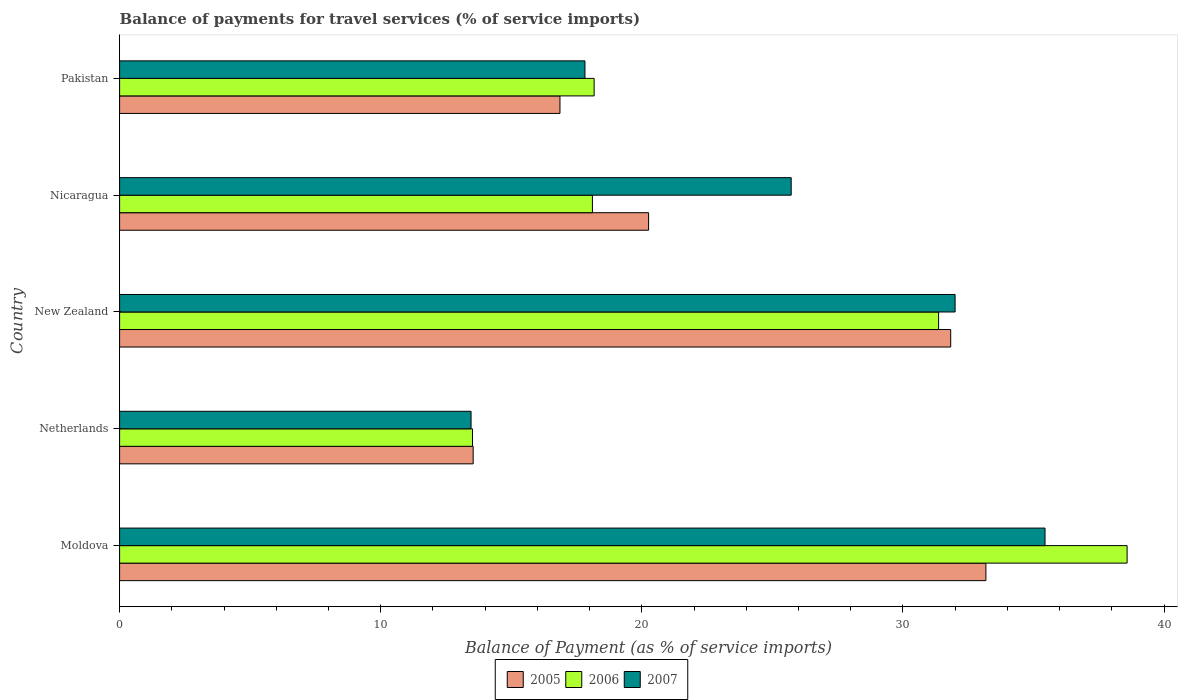How many groups of bars are there?
Provide a succinct answer. 5. Are the number of bars per tick equal to the number of legend labels?
Make the answer very short. Yes. How many bars are there on the 5th tick from the bottom?
Your answer should be very brief. 3. What is the label of the 2nd group of bars from the top?
Your response must be concise. Nicaragua. What is the balance of payments for travel services in 2006 in Nicaragua?
Keep it short and to the point. 18.11. Across all countries, what is the maximum balance of payments for travel services in 2005?
Give a very brief answer. 33.18. Across all countries, what is the minimum balance of payments for travel services in 2006?
Your answer should be very brief. 13.51. In which country was the balance of payments for travel services in 2005 maximum?
Provide a short and direct response. Moldova. In which country was the balance of payments for travel services in 2007 minimum?
Make the answer very short. Netherlands. What is the total balance of payments for travel services in 2007 in the graph?
Provide a succinct answer. 124.44. What is the difference between the balance of payments for travel services in 2006 in Nicaragua and that in Pakistan?
Offer a terse response. -0.07. What is the difference between the balance of payments for travel services in 2006 in New Zealand and the balance of payments for travel services in 2007 in Netherlands?
Your answer should be very brief. 17.91. What is the average balance of payments for travel services in 2007 per country?
Offer a very short reply. 24.89. What is the difference between the balance of payments for travel services in 2007 and balance of payments for travel services in 2005 in New Zealand?
Your response must be concise. 0.17. In how many countries, is the balance of payments for travel services in 2007 greater than 26 %?
Your answer should be very brief. 2. What is the ratio of the balance of payments for travel services in 2005 in New Zealand to that in Pakistan?
Provide a short and direct response. 1.89. Is the balance of payments for travel services in 2006 in Nicaragua less than that in Pakistan?
Keep it short and to the point. Yes. What is the difference between the highest and the second highest balance of payments for travel services in 2005?
Provide a succinct answer. 1.35. What is the difference between the highest and the lowest balance of payments for travel services in 2007?
Give a very brief answer. 21.98. Is the sum of the balance of payments for travel services in 2005 in Netherlands and Nicaragua greater than the maximum balance of payments for travel services in 2007 across all countries?
Your response must be concise. No. What does the 2nd bar from the top in Pakistan represents?
Provide a succinct answer. 2006. Is it the case that in every country, the sum of the balance of payments for travel services in 2006 and balance of payments for travel services in 2007 is greater than the balance of payments for travel services in 2005?
Make the answer very short. Yes. Are all the bars in the graph horizontal?
Provide a succinct answer. Yes. How many countries are there in the graph?
Make the answer very short. 5. Does the graph contain any zero values?
Your answer should be compact. No. Does the graph contain grids?
Your answer should be compact. No. How many legend labels are there?
Make the answer very short. 3. How are the legend labels stacked?
Provide a succinct answer. Horizontal. What is the title of the graph?
Provide a succinct answer. Balance of payments for travel services (% of service imports). Does "1986" appear as one of the legend labels in the graph?
Your answer should be very brief. No. What is the label or title of the X-axis?
Ensure brevity in your answer.  Balance of Payment (as % of service imports). What is the Balance of Payment (as % of service imports) in 2005 in Moldova?
Your answer should be very brief. 33.18. What is the Balance of Payment (as % of service imports) in 2006 in Moldova?
Give a very brief answer. 38.58. What is the Balance of Payment (as % of service imports) of 2007 in Moldova?
Offer a terse response. 35.44. What is the Balance of Payment (as % of service imports) in 2005 in Netherlands?
Provide a succinct answer. 13.54. What is the Balance of Payment (as % of service imports) in 2006 in Netherlands?
Your answer should be compact. 13.51. What is the Balance of Payment (as % of service imports) in 2007 in Netherlands?
Your response must be concise. 13.46. What is the Balance of Payment (as % of service imports) in 2005 in New Zealand?
Keep it short and to the point. 31.83. What is the Balance of Payment (as % of service imports) in 2006 in New Zealand?
Ensure brevity in your answer.  31.36. What is the Balance of Payment (as % of service imports) of 2007 in New Zealand?
Your answer should be very brief. 32. What is the Balance of Payment (as % of service imports) in 2005 in Nicaragua?
Make the answer very short. 20.26. What is the Balance of Payment (as % of service imports) in 2006 in Nicaragua?
Provide a succinct answer. 18.11. What is the Balance of Payment (as % of service imports) in 2007 in Nicaragua?
Your answer should be very brief. 25.72. What is the Balance of Payment (as % of service imports) of 2005 in Pakistan?
Keep it short and to the point. 16.86. What is the Balance of Payment (as % of service imports) in 2006 in Pakistan?
Keep it short and to the point. 18.17. What is the Balance of Payment (as % of service imports) of 2007 in Pakistan?
Your response must be concise. 17.82. Across all countries, what is the maximum Balance of Payment (as % of service imports) of 2005?
Give a very brief answer. 33.18. Across all countries, what is the maximum Balance of Payment (as % of service imports) in 2006?
Give a very brief answer. 38.58. Across all countries, what is the maximum Balance of Payment (as % of service imports) in 2007?
Offer a terse response. 35.44. Across all countries, what is the minimum Balance of Payment (as % of service imports) of 2005?
Provide a short and direct response. 13.54. Across all countries, what is the minimum Balance of Payment (as % of service imports) in 2006?
Provide a succinct answer. 13.51. Across all countries, what is the minimum Balance of Payment (as % of service imports) in 2007?
Make the answer very short. 13.46. What is the total Balance of Payment (as % of service imports) in 2005 in the graph?
Provide a succinct answer. 115.67. What is the total Balance of Payment (as % of service imports) of 2006 in the graph?
Provide a short and direct response. 119.74. What is the total Balance of Payment (as % of service imports) of 2007 in the graph?
Keep it short and to the point. 124.44. What is the difference between the Balance of Payment (as % of service imports) of 2005 in Moldova and that in Netherlands?
Your response must be concise. 19.64. What is the difference between the Balance of Payment (as % of service imports) in 2006 in Moldova and that in Netherlands?
Keep it short and to the point. 25.07. What is the difference between the Balance of Payment (as % of service imports) in 2007 in Moldova and that in Netherlands?
Make the answer very short. 21.98. What is the difference between the Balance of Payment (as % of service imports) in 2005 in Moldova and that in New Zealand?
Provide a succinct answer. 1.35. What is the difference between the Balance of Payment (as % of service imports) in 2006 in Moldova and that in New Zealand?
Make the answer very short. 7.22. What is the difference between the Balance of Payment (as % of service imports) in 2007 in Moldova and that in New Zealand?
Make the answer very short. 3.44. What is the difference between the Balance of Payment (as % of service imports) in 2005 in Moldova and that in Nicaragua?
Provide a short and direct response. 12.92. What is the difference between the Balance of Payment (as % of service imports) of 2006 in Moldova and that in Nicaragua?
Keep it short and to the point. 20.48. What is the difference between the Balance of Payment (as % of service imports) in 2007 in Moldova and that in Nicaragua?
Your answer should be very brief. 9.72. What is the difference between the Balance of Payment (as % of service imports) of 2005 in Moldova and that in Pakistan?
Ensure brevity in your answer.  16.31. What is the difference between the Balance of Payment (as % of service imports) in 2006 in Moldova and that in Pakistan?
Your answer should be compact. 20.41. What is the difference between the Balance of Payment (as % of service imports) of 2007 in Moldova and that in Pakistan?
Provide a succinct answer. 17.62. What is the difference between the Balance of Payment (as % of service imports) of 2005 in Netherlands and that in New Zealand?
Offer a very short reply. -18.29. What is the difference between the Balance of Payment (as % of service imports) in 2006 in Netherlands and that in New Zealand?
Offer a terse response. -17.85. What is the difference between the Balance of Payment (as % of service imports) of 2007 in Netherlands and that in New Zealand?
Keep it short and to the point. -18.54. What is the difference between the Balance of Payment (as % of service imports) of 2005 in Netherlands and that in Nicaragua?
Provide a succinct answer. -6.72. What is the difference between the Balance of Payment (as % of service imports) of 2006 in Netherlands and that in Nicaragua?
Ensure brevity in your answer.  -4.59. What is the difference between the Balance of Payment (as % of service imports) in 2007 in Netherlands and that in Nicaragua?
Your answer should be very brief. -12.26. What is the difference between the Balance of Payment (as % of service imports) in 2005 in Netherlands and that in Pakistan?
Provide a short and direct response. -3.32. What is the difference between the Balance of Payment (as % of service imports) in 2006 in Netherlands and that in Pakistan?
Provide a succinct answer. -4.66. What is the difference between the Balance of Payment (as % of service imports) in 2007 in Netherlands and that in Pakistan?
Give a very brief answer. -4.36. What is the difference between the Balance of Payment (as % of service imports) in 2005 in New Zealand and that in Nicaragua?
Make the answer very short. 11.57. What is the difference between the Balance of Payment (as % of service imports) in 2006 in New Zealand and that in Nicaragua?
Your answer should be compact. 13.26. What is the difference between the Balance of Payment (as % of service imports) in 2007 in New Zealand and that in Nicaragua?
Your answer should be very brief. 6.28. What is the difference between the Balance of Payment (as % of service imports) of 2005 in New Zealand and that in Pakistan?
Provide a short and direct response. 14.96. What is the difference between the Balance of Payment (as % of service imports) in 2006 in New Zealand and that in Pakistan?
Keep it short and to the point. 13.19. What is the difference between the Balance of Payment (as % of service imports) in 2007 in New Zealand and that in Pakistan?
Make the answer very short. 14.18. What is the difference between the Balance of Payment (as % of service imports) in 2005 in Nicaragua and that in Pakistan?
Make the answer very short. 3.39. What is the difference between the Balance of Payment (as % of service imports) in 2006 in Nicaragua and that in Pakistan?
Make the answer very short. -0.07. What is the difference between the Balance of Payment (as % of service imports) in 2007 in Nicaragua and that in Pakistan?
Ensure brevity in your answer.  7.9. What is the difference between the Balance of Payment (as % of service imports) of 2005 in Moldova and the Balance of Payment (as % of service imports) of 2006 in Netherlands?
Your answer should be very brief. 19.66. What is the difference between the Balance of Payment (as % of service imports) in 2005 in Moldova and the Balance of Payment (as % of service imports) in 2007 in Netherlands?
Your response must be concise. 19.72. What is the difference between the Balance of Payment (as % of service imports) of 2006 in Moldova and the Balance of Payment (as % of service imports) of 2007 in Netherlands?
Your answer should be compact. 25.12. What is the difference between the Balance of Payment (as % of service imports) in 2005 in Moldova and the Balance of Payment (as % of service imports) in 2006 in New Zealand?
Keep it short and to the point. 1.81. What is the difference between the Balance of Payment (as % of service imports) of 2005 in Moldova and the Balance of Payment (as % of service imports) of 2007 in New Zealand?
Ensure brevity in your answer.  1.18. What is the difference between the Balance of Payment (as % of service imports) in 2006 in Moldova and the Balance of Payment (as % of service imports) in 2007 in New Zealand?
Offer a terse response. 6.59. What is the difference between the Balance of Payment (as % of service imports) in 2005 in Moldova and the Balance of Payment (as % of service imports) in 2006 in Nicaragua?
Provide a succinct answer. 15.07. What is the difference between the Balance of Payment (as % of service imports) in 2005 in Moldova and the Balance of Payment (as % of service imports) in 2007 in Nicaragua?
Your answer should be compact. 7.46. What is the difference between the Balance of Payment (as % of service imports) in 2006 in Moldova and the Balance of Payment (as % of service imports) in 2007 in Nicaragua?
Give a very brief answer. 12.86. What is the difference between the Balance of Payment (as % of service imports) of 2005 in Moldova and the Balance of Payment (as % of service imports) of 2006 in Pakistan?
Ensure brevity in your answer.  15. What is the difference between the Balance of Payment (as % of service imports) in 2005 in Moldova and the Balance of Payment (as % of service imports) in 2007 in Pakistan?
Give a very brief answer. 15.36. What is the difference between the Balance of Payment (as % of service imports) of 2006 in Moldova and the Balance of Payment (as % of service imports) of 2007 in Pakistan?
Offer a very short reply. 20.76. What is the difference between the Balance of Payment (as % of service imports) in 2005 in Netherlands and the Balance of Payment (as % of service imports) in 2006 in New Zealand?
Your answer should be compact. -17.82. What is the difference between the Balance of Payment (as % of service imports) of 2005 in Netherlands and the Balance of Payment (as % of service imports) of 2007 in New Zealand?
Provide a succinct answer. -18.46. What is the difference between the Balance of Payment (as % of service imports) of 2006 in Netherlands and the Balance of Payment (as % of service imports) of 2007 in New Zealand?
Offer a very short reply. -18.48. What is the difference between the Balance of Payment (as % of service imports) of 2005 in Netherlands and the Balance of Payment (as % of service imports) of 2006 in Nicaragua?
Your answer should be very brief. -4.57. What is the difference between the Balance of Payment (as % of service imports) of 2005 in Netherlands and the Balance of Payment (as % of service imports) of 2007 in Nicaragua?
Your response must be concise. -12.18. What is the difference between the Balance of Payment (as % of service imports) in 2006 in Netherlands and the Balance of Payment (as % of service imports) in 2007 in Nicaragua?
Provide a short and direct response. -12.21. What is the difference between the Balance of Payment (as % of service imports) of 2005 in Netherlands and the Balance of Payment (as % of service imports) of 2006 in Pakistan?
Your answer should be compact. -4.63. What is the difference between the Balance of Payment (as % of service imports) of 2005 in Netherlands and the Balance of Payment (as % of service imports) of 2007 in Pakistan?
Offer a very short reply. -4.28. What is the difference between the Balance of Payment (as % of service imports) in 2006 in Netherlands and the Balance of Payment (as % of service imports) in 2007 in Pakistan?
Offer a very short reply. -4.31. What is the difference between the Balance of Payment (as % of service imports) of 2005 in New Zealand and the Balance of Payment (as % of service imports) of 2006 in Nicaragua?
Give a very brief answer. 13.72. What is the difference between the Balance of Payment (as % of service imports) in 2005 in New Zealand and the Balance of Payment (as % of service imports) in 2007 in Nicaragua?
Your answer should be compact. 6.11. What is the difference between the Balance of Payment (as % of service imports) of 2006 in New Zealand and the Balance of Payment (as % of service imports) of 2007 in Nicaragua?
Your response must be concise. 5.65. What is the difference between the Balance of Payment (as % of service imports) of 2005 in New Zealand and the Balance of Payment (as % of service imports) of 2006 in Pakistan?
Offer a terse response. 13.66. What is the difference between the Balance of Payment (as % of service imports) in 2005 in New Zealand and the Balance of Payment (as % of service imports) in 2007 in Pakistan?
Provide a succinct answer. 14.01. What is the difference between the Balance of Payment (as % of service imports) in 2006 in New Zealand and the Balance of Payment (as % of service imports) in 2007 in Pakistan?
Offer a terse response. 13.54. What is the difference between the Balance of Payment (as % of service imports) in 2005 in Nicaragua and the Balance of Payment (as % of service imports) in 2006 in Pakistan?
Offer a terse response. 2.09. What is the difference between the Balance of Payment (as % of service imports) in 2005 in Nicaragua and the Balance of Payment (as % of service imports) in 2007 in Pakistan?
Provide a short and direct response. 2.44. What is the difference between the Balance of Payment (as % of service imports) in 2006 in Nicaragua and the Balance of Payment (as % of service imports) in 2007 in Pakistan?
Keep it short and to the point. 0.29. What is the average Balance of Payment (as % of service imports) of 2005 per country?
Give a very brief answer. 23.13. What is the average Balance of Payment (as % of service imports) in 2006 per country?
Offer a very short reply. 23.95. What is the average Balance of Payment (as % of service imports) of 2007 per country?
Your answer should be compact. 24.89. What is the difference between the Balance of Payment (as % of service imports) in 2005 and Balance of Payment (as % of service imports) in 2006 in Moldova?
Provide a succinct answer. -5.41. What is the difference between the Balance of Payment (as % of service imports) of 2005 and Balance of Payment (as % of service imports) of 2007 in Moldova?
Ensure brevity in your answer.  -2.26. What is the difference between the Balance of Payment (as % of service imports) of 2006 and Balance of Payment (as % of service imports) of 2007 in Moldova?
Your answer should be very brief. 3.14. What is the difference between the Balance of Payment (as % of service imports) in 2005 and Balance of Payment (as % of service imports) in 2006 in Netherlands?
Offer a very short reply. 0.03. What is the difference between the Balance of Payment (as % of service imports) in 2005 and Balance of Payment (as % of service imports) in 2007 in Netherlands?
Your answer should be very brief. 0.08. What is the difference between the Balance of Payment (as % of service imports) in 2006 and Balance of Payment (as % of service imports) in 2007 in Netherlands?
Your response must be concise. 0.06. What is the difference between the Balance of Payment (as % of service imports) in 2005 and Balance of Payment (as % of service imports) in 2006 in New Zealand?
Make the answer very short. 0.46. What is the difference between the Balance of Payment (as % of service imports) of 2005 and Balance of Payment (as % of service imports) of 2007 in New Zealand?
Offer a terse response. -0.17. What is the difference between the Balance of Payment (as % of service imports) of 2006 and Balance of Payment (as % of service imports) of 2007 in New Zealand?
Make the answer very short. -0.63. What is the difference between the Balance of Payment (as % of service imports) in 2005 and Balance of Payment (as % of service imports) in 2006 in Nicaragua?
Keep it short and to the point. 2.15. What is the difference between the Balance of Payment (as % of service imports) of 2005 and Balance of Payment (as % of service imports) of 2007 in Nicaragua?
Give a very brief answer. -5.46. What is the difference between the Balance of Payment (as % of service imports) of 2006 and Balance of Payment (as % of service imports) of 2007 in Nicaragua?
Provide a short and direct response. -7.61. What is the difference between the Balance of Payment (as % of service imports) of 2005 and Balance of Payment (as % of service imports) of 2006 in Pakistan?
Your answer should be compact. -1.31. What is the difference between the Balance of Payment (as % of service imports) of 2005 and Balance of Payment (as % of service imports) of 2007 in Pakistan?
Your answer should be compact. -0.96. What is the difference between the Balance of Payment (as % of service imports) in 2006 and Balance of Payment (as % of service imports) in 2007 in Pakistan?
Give a very brief answer. 0.35. What is the ratio of the Balance of Payment (as % of service imports) in 2005 in Moldova to that in Netherlands?
Keep it short and to the point. 2.45. What is the ratio of the Balance of Payment (as % of service imports) of 2006 in Moldova to that in Netherlands?
Keep it short and to the point. 2.86. What is the ratio of the Balance of Payment (as % of service imports) in 2007 in Moldova to that in Netherlands?
Keep it short and to the point. 2.63. What is the ratio of the Balance of Payment (as % of service imports) in 2005 in Moldova to that in New Zealand?
Keep it short and to the point. 1.04. What is the ratio of the Balance of Payment (as % of service imports) of 2006 in Moldova to that in New Zealand?
Ensure brevity in your answer.  1.23. What is the ratio of the Balance of Payment (as % of service imports) in 2007 in Moldova to that in New Zealand?
Ensure brevity in your answer.  1.11. What is the ratio of the Balance of Payment (as % of service imports) of 2005 in Moldova to that in Nicaragua?
Your answer should be very brief. 1.64. What is the ratio of the Balance of Payment (as % of service imports) in 2006 in Moldova to that in Nicaragua?
Give a very brief answer. 2.13. What is the ratio of the Balance of Payment (as % of service imports) of 2007 in Moldova to that in Nicaragua?
Ensure brevity in your answer.  1.38. What is the ratio of the Balance of Payment (as % of service imports) of 2005 in Moldova to that in Pakistan?
Your response must be concise. 1.97. What is the ratio of the Balance of Payment (as % of service imports) of 2006 in Moldova to that in Pakistan?
Your response must be concise. 2.12. What is the ratio of the Balance of Payment (as % of service imports) of 2007 in Moldova to that in Pakistan?
Provide a succinct answer. 1.99. What is the ratio of the Balance of Payment (as % of service imports) of 2005 in Netherlands to that in New Zealand?
Provide a succinct answer. 0.43. What is the ratio of the Balance of Payment (as % of service imports) in 2006 in Netherlands to that in New Zealand?
Your answer should be compact. 0.43. What is the ratio of the Balance of Payment (as % of service imports) in 2007 in Netherlands to that in New Zealand?
Provide a short and direct response. 0.42. What is the ratio of the Balance of Payment (as % of service imports) of 2005 in Netherlands to that in Nicaragua?
Offer a very short reply. 0.67. What is the ratio of the Balance of Payment (as % of service imports) in 2006 in Netherlands to that in Nicaragua?
Provide a short and direct response. 0.75. What is the ratio of the Balance of Payment (as % of service imports) of 2007 in Netherlands to that in Nicaragua?
Make the answer very short. 0.52. What is the ratio of the Balance of Payment (as % of service imports) in 2005 in Netherlands to that in Pakistan?
Your answer should be compact. 0.8. What is the ratio of the Balance of Payment (as % of service imports) in 2006 in Netherlands to that in Pakistan?
Your answer should be compact. 0.74. What is the ratio of the Balance of Payment (as % of service imports) of 2007 in Netherlands to that in Pakistan?
Offer a terse response. 0.76. What is the ratio of the Balance of Payment (as % of service imports) of 2005 in New Zealand to that in Nicaragua?
Offer a terse response. 1.57. What is the ratio of the Balance of Payment (as % of service imports) in 2006 in New Zealand to that in Nicaragua?
Make the answer very short. 1.73. What is the ratio of the Balance of Payment (as % of service imports) of 2007 in New Zealand to that in Nicaragua?
Offer a terse response. 1.24. What is the ratio of the Balance of Payment (as % of service imports) in 2005 in New Zealand to that in Pakistan?
Give a very brief answer. 1.89. What is the ratio of the Balance of Payment (as % of service imports) in 2006 in New Zealand to that in Pakistan?
Provide a short and direct response. 1.73. What is the ratio of the Balance of Payment (as % of service imports) in 2007 in New Zealand to that in Pakistan?
Offer a very short reply. 1.8. What is the ratio of the Balance of Payment (as % of service imports) of 2005 in Nicaragua to that in Pakistan?
Offer a very short reply. 1.2. What is the ratio of the Balance of Payment (as % of service imports) in 2006 in Nicaragua to that in Pakistan?
Offer a very short reply. 1. What is the ratio of the Balance of Payment (as % of service imports) of 2007 in Nicaragua to that in Pakistan?
Ensure brevity in your answer.  1.44. What is the difference between the highest and the second highest Balance of Payment (as % of service imports) in 2005?
Your answer should be very brief. 1.35. What is the difference between the highest and the second highest Balance of Payment (as % of service imports) of 2006?
Give a very brief answer. 7.22. What is the difference between the highest and the second highest Balance of Payment (as % of service imports) in 2007?
Your answer should be very brief. 3.44. What is the difference between the highest and the lowest Balance of Payment (as % of service imports) of 2005?
Your answer should be compact. 19.64. What is the difference between the highest and the lowest Balance of Payment (as % of service imports) in 2006?
Ensure brevity in your answer.  25.07. What is the difference between the highest and the lowest Balance of Payment (as % of service imports) of 2007?
Provide a succinct answer. 21.98. 